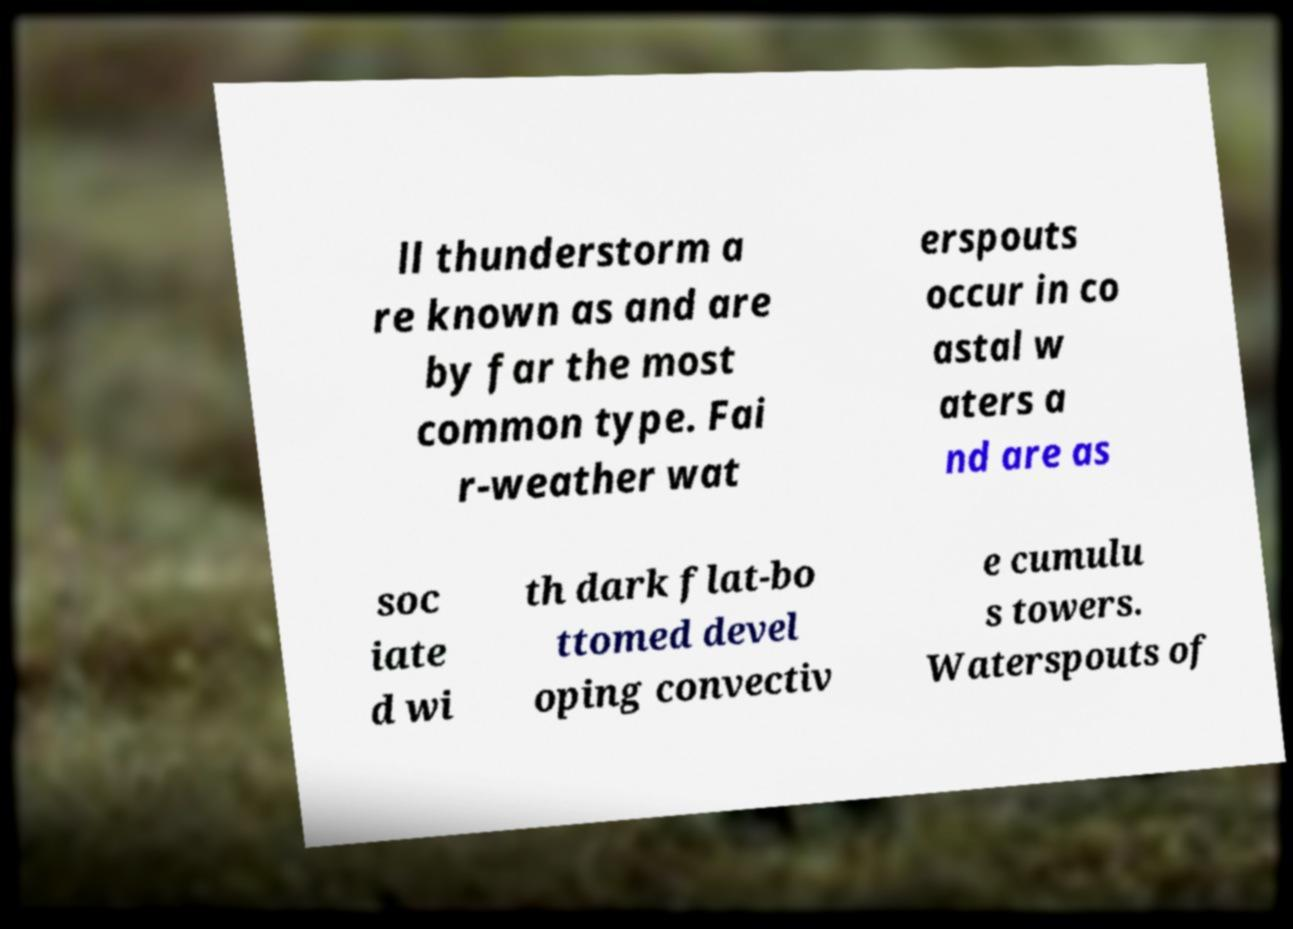Please identify and transcribe the text found in this image. ll thunderstorm a re known as and are by far the most common type. Fai r-weather wat erspouts occur in co astal w aters a nd are as soc iate d wi th dark flat-bo ttomed devel oping convectiv e cumulu s towers. Waterspouts of 